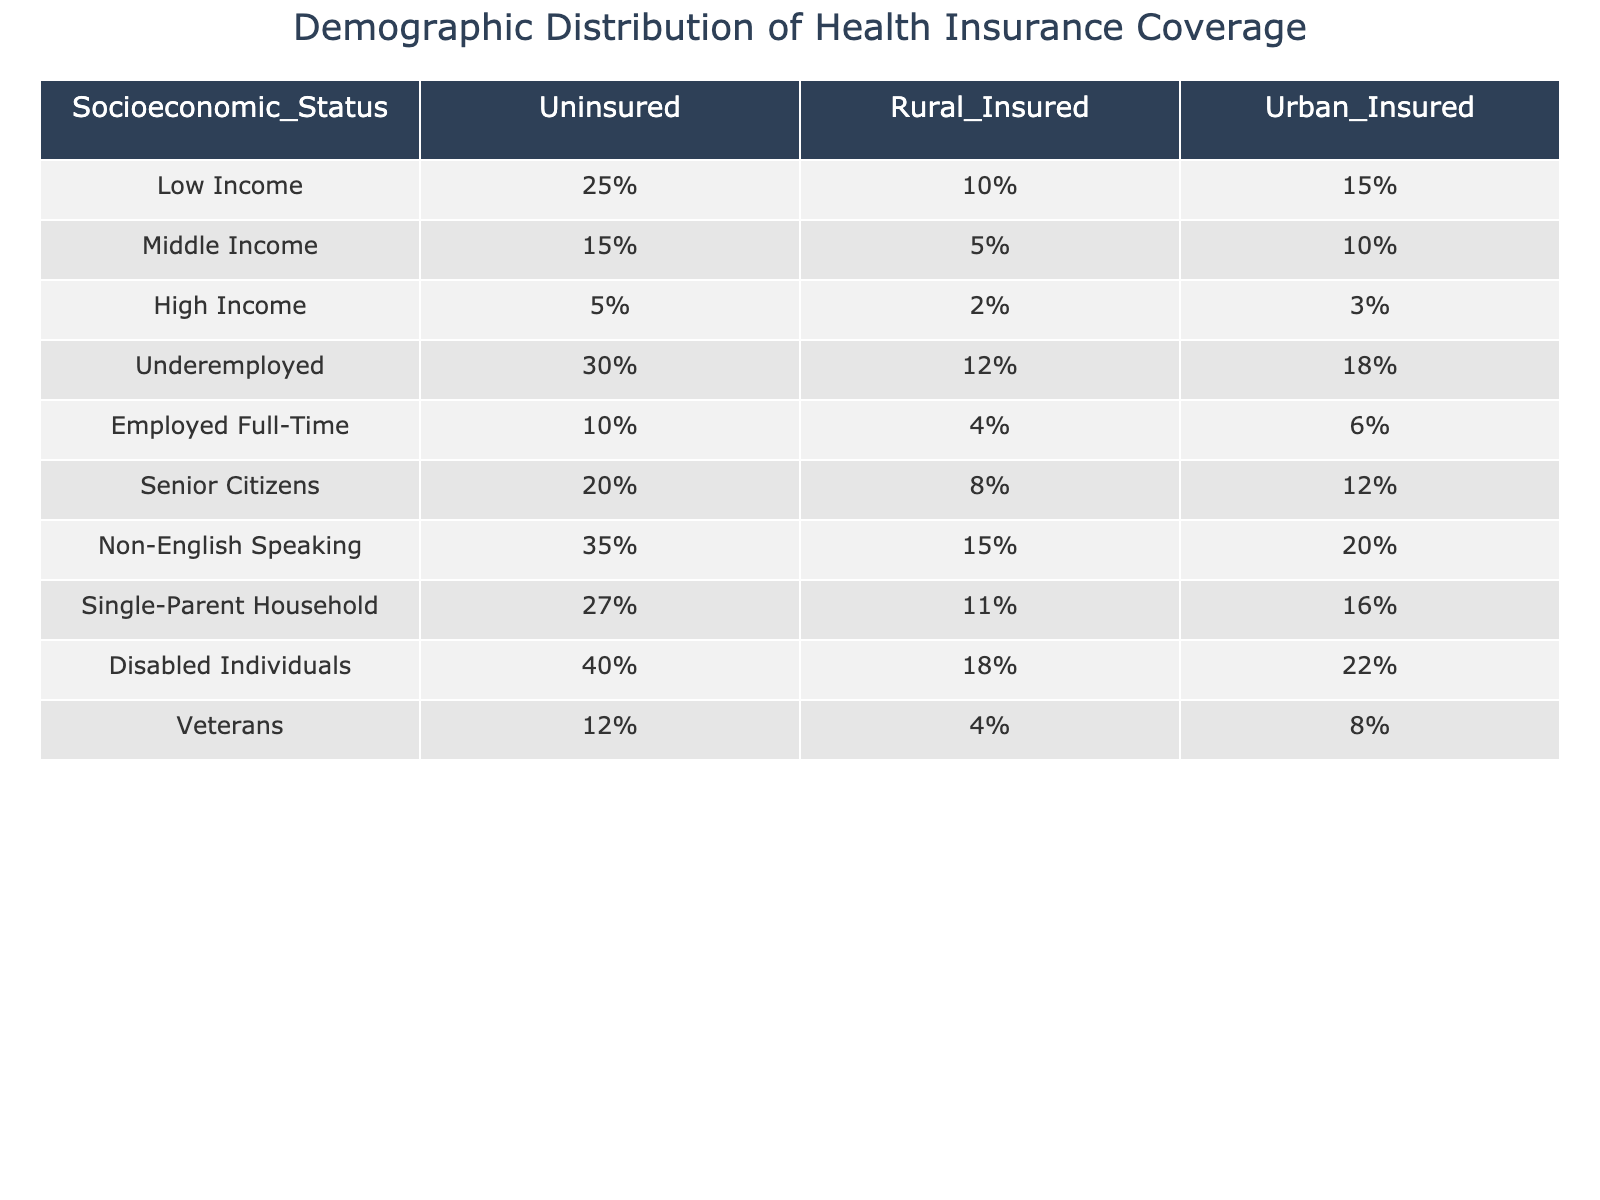What percentage of Low Income individuals are uninsured? The table indicates that 25% of individuals classified as Low Income are uninsured, as this value is directly presented in the table under the "Uninsured" column for the "Low Income" row.
Answer: 25% What is the difference in uninsured rates between Non-English Speaking individuals and High Income individuals? The uninsured rate for Non-English Speaking individuals is 35% and for High Income individuals is 5%. The difference is calculated as 35% - 5% = 30%.
Answer: 30% Are Senior Citizens more likely to be uninsured than Middle Income individuals? The table shows that 20% of Senior Citizens are uninsured while 15% of Middle Income individuals are uninsured. Since 20% is greater than 15%, the statement is true.
Answer: Yes Which socioeconomic group has the highest percentage of uninsured individuals? By comparing the uninsured rates for all groups, we see that Disabled Individuals have the highest rate at 40%. Thus, they represent the group with the most uninsured individuals.
Answer: Disabled Individuals What is the average percentage of urban insurance coverage among Seniors, Non-English Speaking, and Disabled individuals? The urban insurance coverage percentages for Senior Citizens, Non-English Speaking, and Disabled Individuals are 12%, 20%, and 22%, respectively. The average is calculated as (12% + 20% + 22%)/3 = 18%.
Answer: 18% What is the combined percentage of uninsured individuals from Employed Full-Time and Veterans? The uninsured rates for Employed Full-Time and Veterans are 10% and 12%, respectively. The combined percentage is 10% + 12% = 22%.
Answer: 22% Does any socioeconomic group have an insured rate for rural areas below 10%? Looking at the table, the groups with rural insured rates are Low Income (10%), Middle Income (5%), High Income (2%), Underemployed (12%), Employed Full-Time (4%), Senior Citizens (8%), Non-English Speaking (15%), Single-Parent Household (11%), Disabled Individuals (18%), and Veterans (4%). The groups Low Income, Middle Income, and High Income all have rates below 10%, so the answer is yes.
Answer: Yes What is the sum of urban insurance coverage rates for Underemployed and Low Income individuals? The urban insurance coverage for Underemployed individuals is 18% and for Low Income individuals, it is 15%. The sum is calculated as 18% + 15% = 33%.
Answer: 33% Which group has the lowest percentage of rural insurance coverage? Looking at the rural insurance coverage rates, High Income has the lowest of 2%. Thus, it is identified as the group with the least percentage of rural insurance coverage.
Answer: High Income 